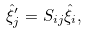<formula> <loc_0><loc_0><loc_500><loc_500>\hat { \xi } ^ { \prime } _ { j } = S _ { i j } \hat { \xi } _ { i } ,</formula> 